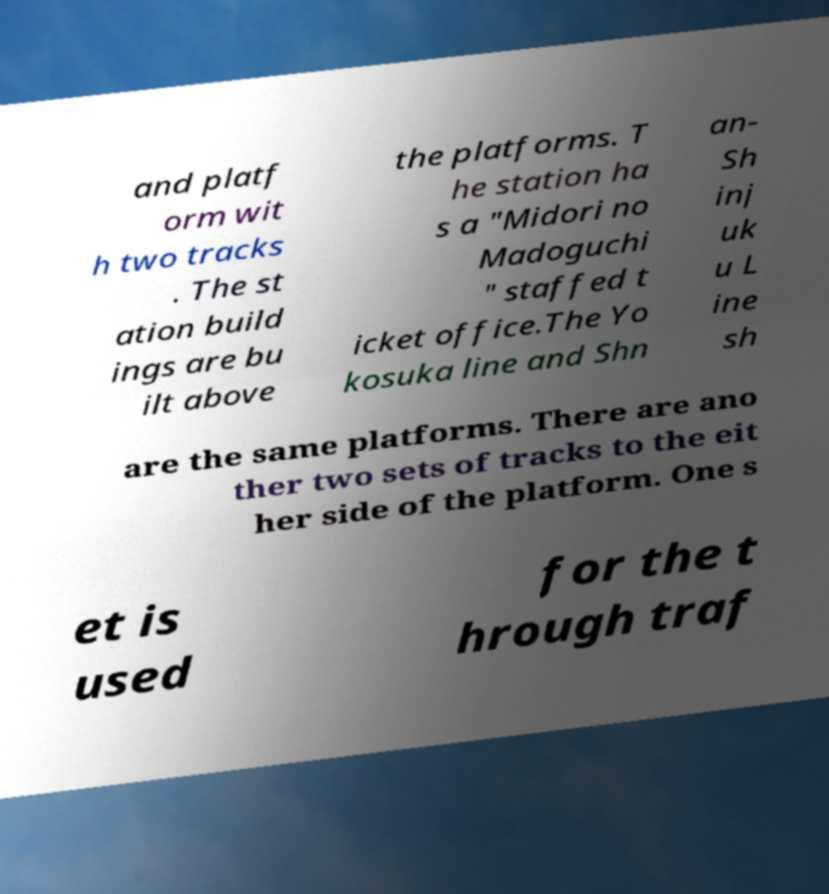Please read and relay the text visible in this image. What does it say? and platf orm wit h two tracks . The st ation build ings are bu ilt above the platforms. T he station ha s a "Midori no Madoguchi " staffed t icket office.The Yo kosuka line and Shn an- Sh inj uk u L ine sh are the same platforms. There are ano ther two sets of tracks to the eit her side of the platform. One s et is used for the t hrough traf 